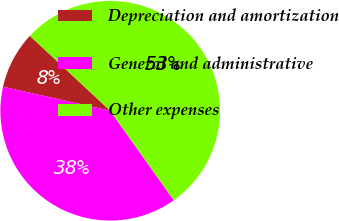<chart> <loc_0><loc_0><loc_500><loc_500><pie_chart><fcel>Depreciation and amortization<fcel>General and administrative<fcel>Other expenses<nl><fcel>8.44%<fcel>38.34%<fcel>53.22%<nl></chart> 